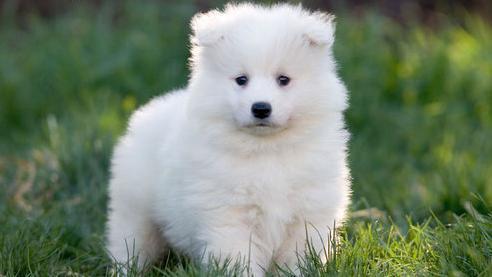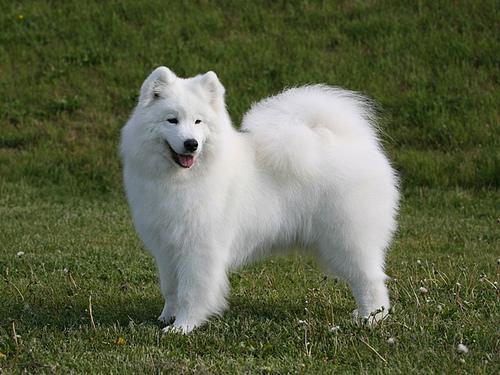The first image is the image on the left, the second image is the image on the right. Analyze the images presented: Is the assertion "There are no more than three dogs" valid? Answer yes or no. Yes. 